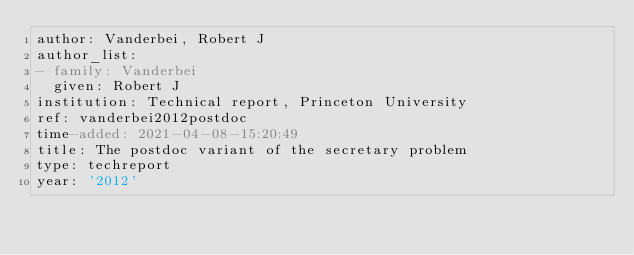Convert code to text. <code><loc_0><loc_0><loc_500><loc_500><_YAML_>author: Vanderbei, Robert J
author_list:
- family: Vanderbei
  given: Robert J
institution: Technical report, Princeton University
ref: vanderbei2012postdoc
time-added: 2021-04-08-15:20:49
title: The postdoc variant of the secretary problem
type: techreport
year: '2012'
</code> 